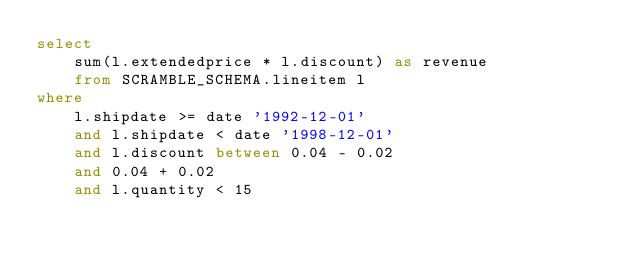Convert code to text. <code><loc_0><loc_0><loc_500><loc_500><_SQL_>select
    sum(l.extendedprice * l.discount) as revenue
    from SCRAMBLE_SCHEMA.lineitem l
where
    l.shipdate >= date '1992-12-01'
    and l.shipdate < date '1998-12-01'
    and l.discount between 0.04 - 0.02
    and 0.04 + 0.02
    and l.quantity < 15
</code> 